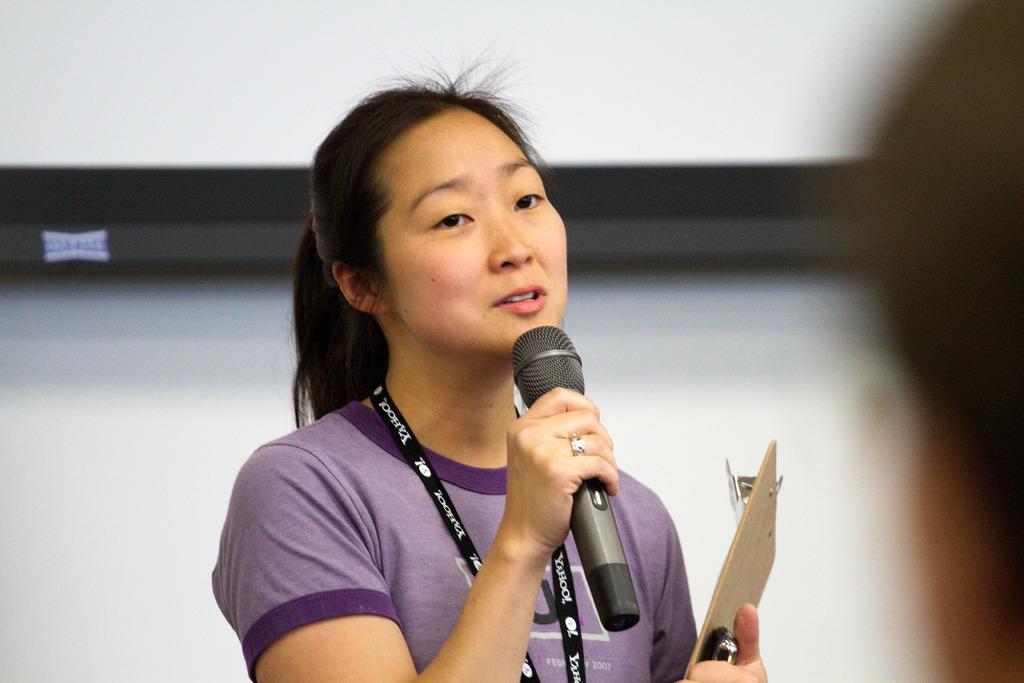Please provide a concise description of this image. A lady in violet dress is wearing a tag and holding mic and writing pad on her hands and speaking. 